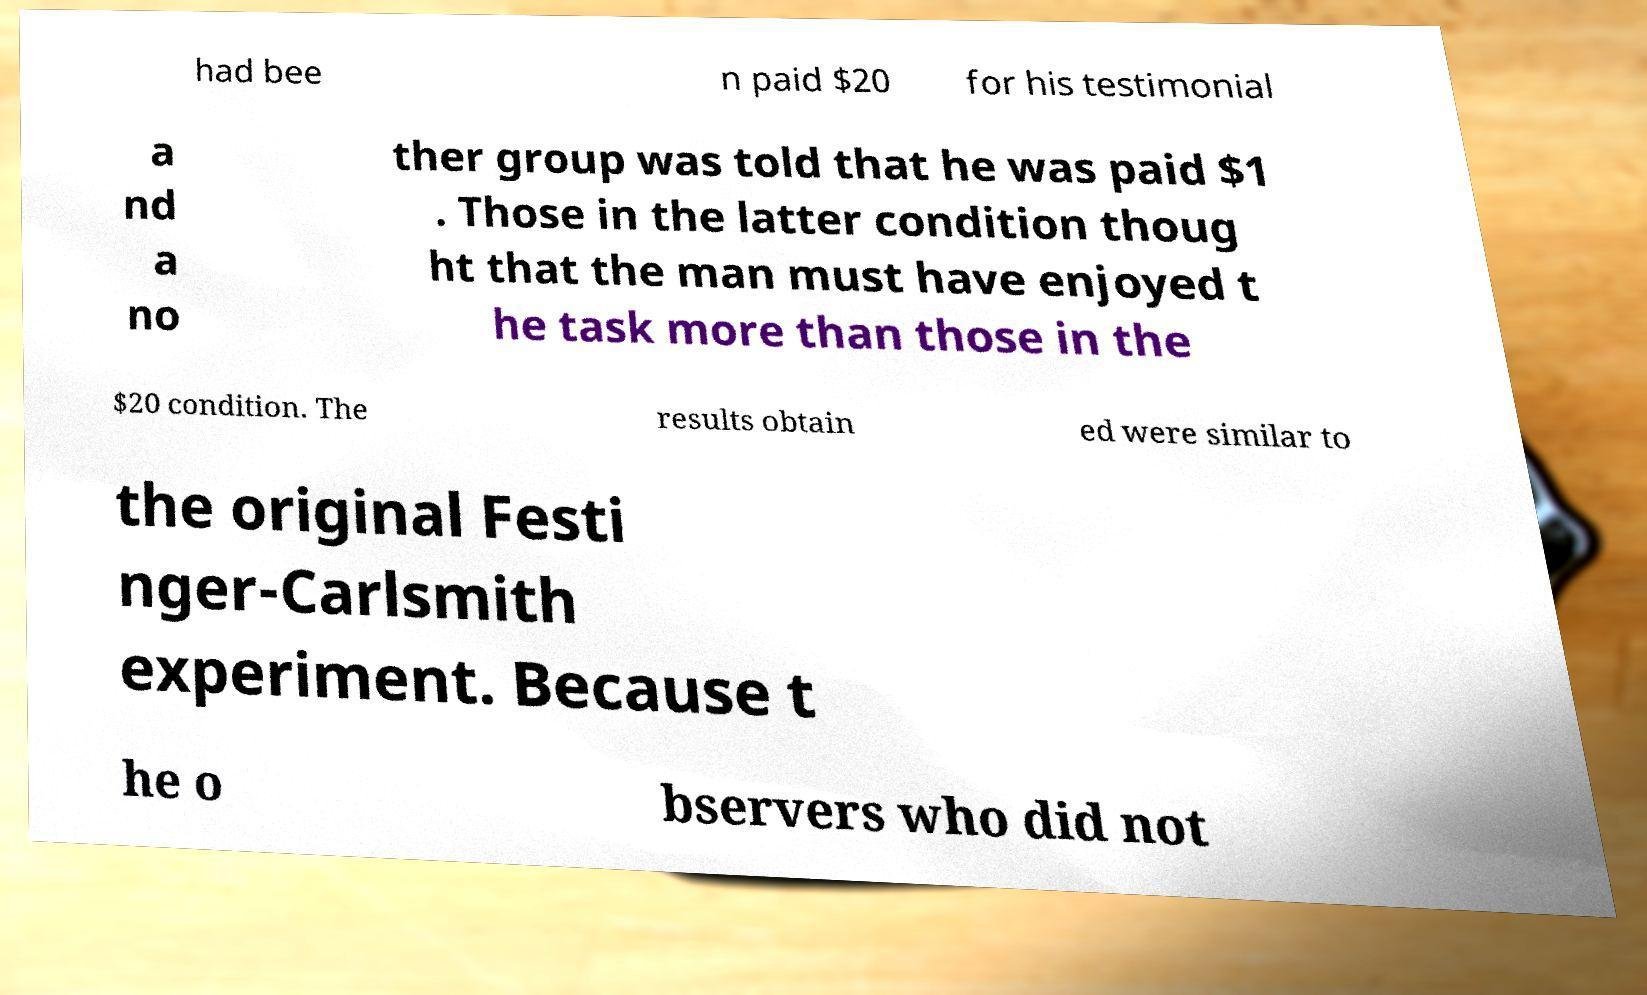Could you assist in decoding the text presented in this image and type it out clearly? had bee n paid $20 for his testimonial a nd a no ther group was told that he was paid $1 . Those in the latter condition thoug ht that the man must have enjoyed t he task more than those in the $20 condition. The results obtain ed were similar to the original Festi nger-Carlsmith experiment. Because t he o bservers who did not 